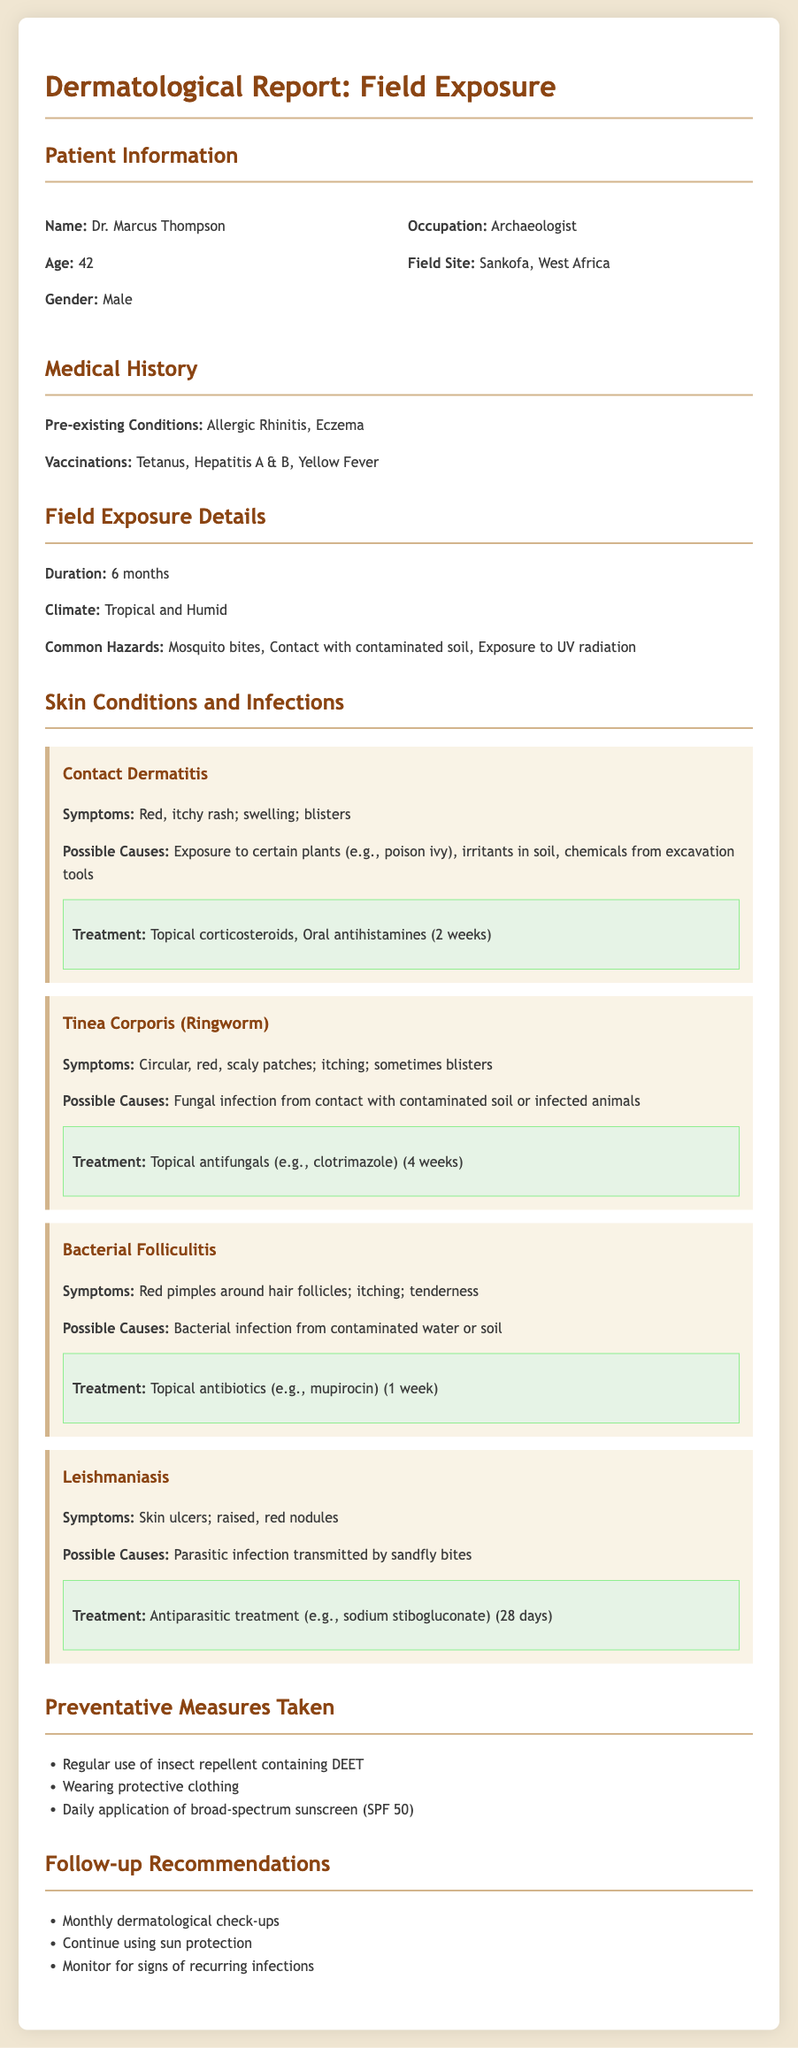What is the name of the patient? The name of the patient is stated in the Patient Information section.
Answer: Dr. Marcus Thompson What is the age of the patient? The patient's age is listed in the Patient Information section.
Answer: 42 What are the pre-existing conditions? The pre-existing conditions are detailed in the Medical History section.
Answer: Allergic Rhinitis, Eczema What is the climate at the field site? The climate is specified in the Field Exposure Details section.
Answer: Tropical and Humid What is the duration of the field exposure? The duration is mentioned in the Field Exposure Details section.
Answer: 6 months What treatment is recommended for Leishmaniasis? The treatment for Leishmaniasis can be found in the Skin Conditions and Infections section.
Answer: Antiparasitic treatment (e.g., sodium stibogluconate) (28 days) What are common hazards listed in the report? Common hazards are specifically mentioned in the Field Exposure Details section.
Answer: Mosquito bites, Contact with contaminated soil, Exposure to UV radiation What is the recommended follow-up for dermatological check-ups? The follow-up recommendations for dermatological check-ups are outlined in the Follow-up Recommendations section.
Answer: Monthly dermatological check-ups Which fungal infection is mentioned in the report? The fungal infection is detailed in the Skin Conditions and Infections section.
Answer: Tinea Corporis (Ringworm) 